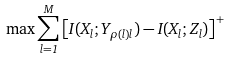Convert formula to latex. <formula><loc_0><loc_0><loc_500><loc_500>\max \sum _ { l = 1 } ^ { M } \left [ I ( X _ { l } ; Y _ { \rho ( l ) l } ) - I ( X _ { l } ; Z _ { l } ) \right ] ^ { + }</formula> 